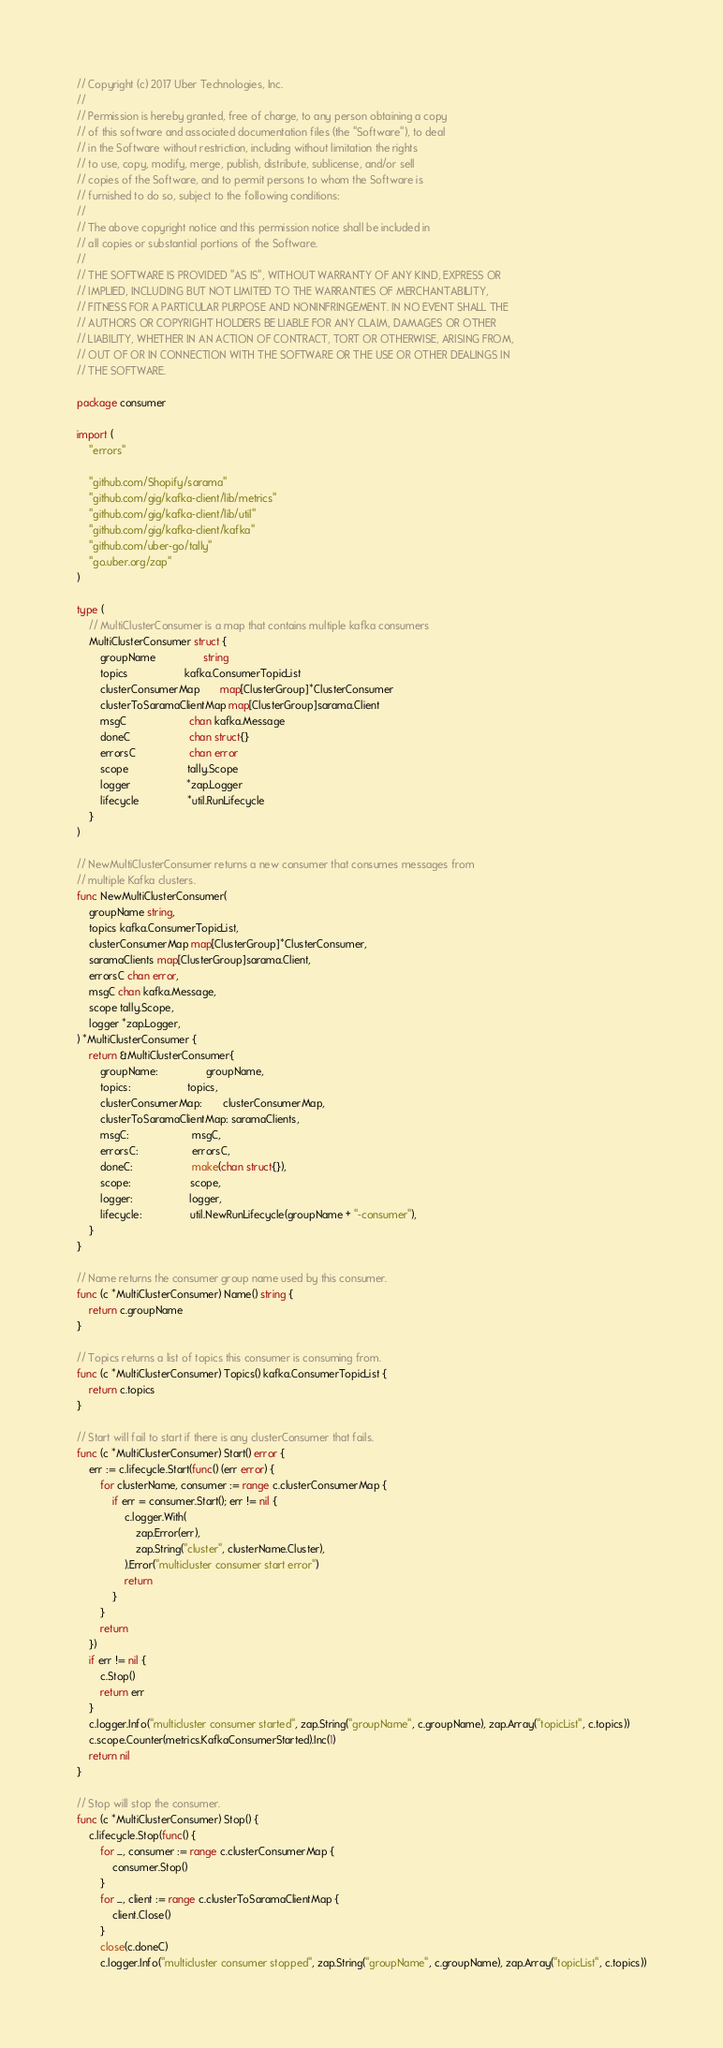Convert code to text. <code><loc_0><loc_0><loc_500><loc_500><_Go_>// Copyright (c) 2017 Uber Technologies, Inc.
//
// Permission is hereby granted, free of charge, to any person obtaining a copy
// of this software and associated documentation files (the "Software"), to deal
// in the Software without restriction, including without limitation the rights
// to use, copy, modify, merge, publish, distribute, sublicense, and/or sell
// copies of the Software, and to permit persons to whom the Software is
// furnished to do so, subject to the following conditions:
//
// The above copyright notice and this permission notice shall be included in
// all copies or substantial portions of the Software.
//
// THE SOFTWARE IS PROVIDED "AS IS", WITHOUT WARRANTY OF ANY KIND, EXPRESS OR
// IMPLIED, INCLUDING BUT NOT LIMITED TO THE WARRANTIES OF MERCHANTABILITY,
// FITNESS FOR A PARTICULAR PURPOSE AND NONINFRINGEMENT. IN NO EVENT SHALL THE
// AUTHORS OR COPYRIGHT HOLDERS BE LIABLE FOR ANY CLAIM, DAMAGES OR OTHER
// LIABILITY, WHETHER IN AN ACTION OF CONTRACT, TORT OR OTHERWISE, ARISING FROM,
// OUT OF OR IN CONNECTION WITH THE SOFTWARE OR THE USE OR OTHER DEALINGS IN
// THE SOFTWARE.

package consumer

import (
	"errors"

	"github.com/Shopify/sarama"
	"github.com/gig/kafka-client/lib/metrics"
	"github.com/gig/kafka-client/lib/util"
	"github.com/gig/kafka-client/kafka"
	"github.com/uber-go/tally"
	"go.uber.org/zap"
)

type (
	// MultiClusterConsumer is a map that contains multiple kafka consumers
	MultiClusterConsumer struct {
		groupName                string
		topics                   kafka.ConsumerTopicList
		clusterConsumerMap       map[ClusterGroup]*ClusterConsumer
		clusterToSaramaClientMap map[ClusterGroup]sarama.Client
		msgC                     chan kafka.Message
		doneC                    chan struct{}
		errorsC                  chan error
		scope                    tally.Scope
		logger                   *zap.Logger
		lifecycle                *util.RunLifecycle
	}
)

// NewMultiClusterConsumer returns a new consumer that consumes messages from
// multiple Kafka clusters.
func NewMultiClusterConsumer(
	groupName string,
	topics kafka.ConsumerTopicList,
	clusterConsumerMap map[ClusterGroup]*ClusterConsumer,
	saramaClients map[ClusterGroup]sarama.Client,
	errorsC chan error,
	msgC chan kafka.Message,
	scope tally.Scope,
	logger *zap.Logger,
) *MultiClusterConsumer {
	return &MultiClusterConsumer{
		groupName:                groupName,
		topics:                   topics,
		clusterConsumerMap:       clusterConsumerMap,
		clusterToSaramaClientMap: saramaClients,
		msgC:                     msgC,
		errorsC:                  errorsC,
		doneC:                    make(chan struct{}),
		scope:                    scope,
		logger:                   logger,
		lifecycle:                util.NewRunLifecycle(groupName + "-consumer"),
	}
}

// Name returns the consumer group name used by this consumer.
func (c *MultiClusterConsumer) Name() string {
	return c.groupName
}

// Topics returns a list of topics this consumer is consuming from.
func (c *MultiClusterConsumer) Topics() kafka.ConsumerTopicList {
	return c.topics
}

// Start will fail to start if there is any clusterConsumer that fails.
func (c *MultiClusterConsumer) Start() error {
	err := c.lifecycle.Start(func() (err error) {
		for clusterName, consumer := range c.clusterConsumerMap {
			if err = consumer.Start(); err != nil {
				c.logger.With(
					zap.Error(err),
					zap.String("cluster", clusterName.Cluster),
				).Error("multicluster consumer start error")
				return
			}
		}
		return
	})
	if err != nil {
		c.Stop()
		return err
	}
	c.logger.Info("multicluster consumer started", zap.String("groupName", c.groupName), zap.Array("topicList", c.topics))
	c.scope.Counter(metrics.KafkaConsumerStarted).Inc(1)
	return nil
}

// Stop will stop the consumer.
func (c *MultiClusterConsumer) Stop() {
	c.lifecycle.Stop(func() {
		for _, consumer := range c.clusterConsumerMap {
			consumer.Stop()
		}
		for _, client := range c.clusterToSaramaClientMap {
			client.Close()
		}
		close(c.doneC)
		c.logger.Info("multicluster consumer stopped", zap.String("groupName", c.groupName), zap.Array("topicList", c.topics))</code> 